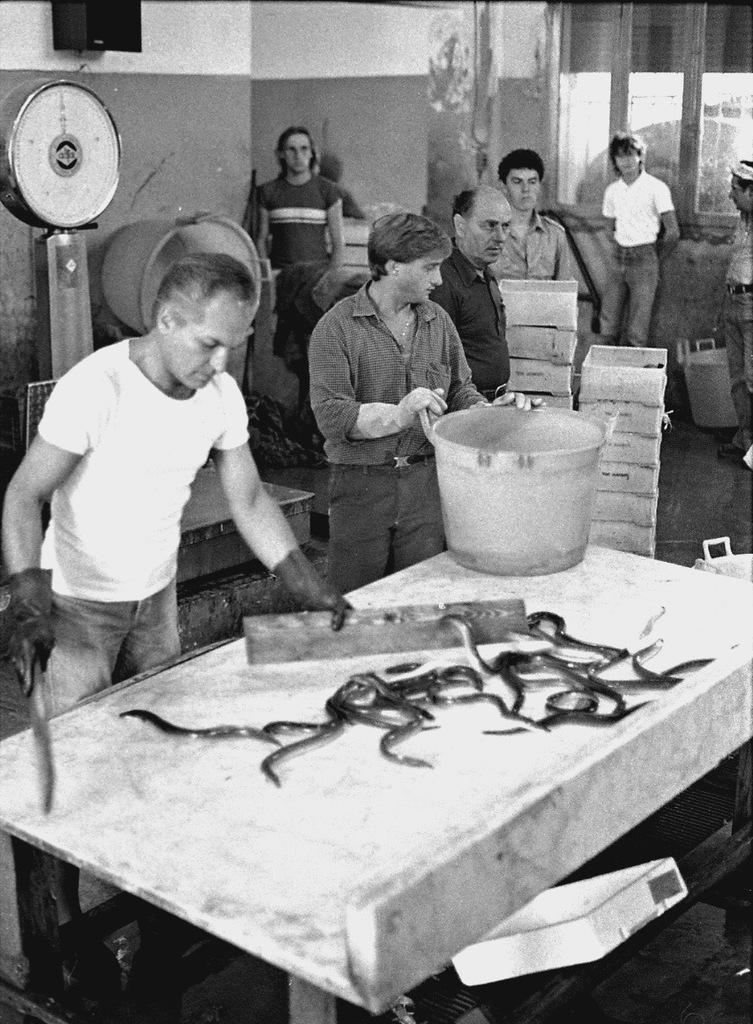Could you give a brief overview of what you see in this image? This picture shows that there are some men who are killing some Snakes on the table. This is a basket on a table. In the background there are some men watching this. There is a wall and a weighing machine here. 